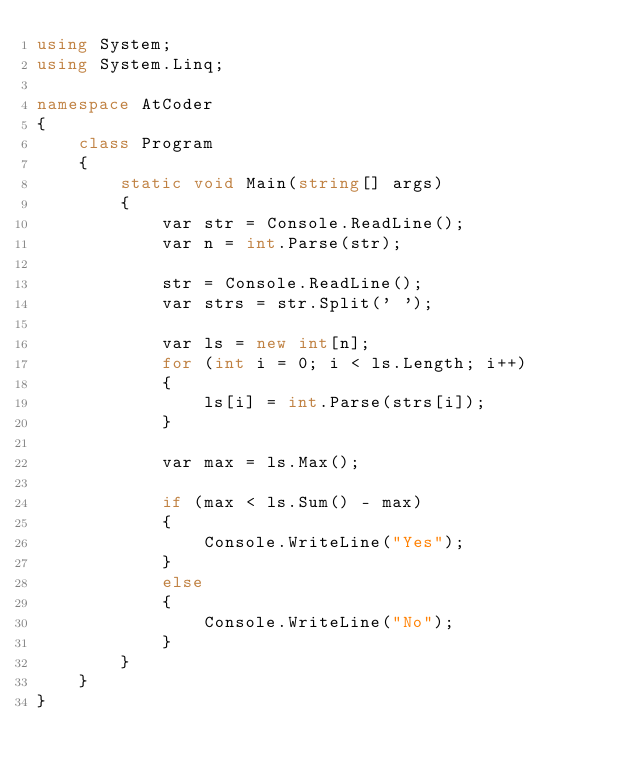<code> <loc_0><loc_0><loc_500><loc_500><_C#_>using System;
using System.Linq;

namespace AtCoder
{
    class Program
    {
        static void Main(string[] args)
        {
            var str = Console.ReadLine();
            var n = int.Parse(str);

            str = Console.ReadLine();
            var strs = str.Split(' ');

            var ls = new int[n];
            for (int i = 0; i < ls.Length; i++)
            {
                ls[i] = int.Parse(strs[i]);
            }

            var max = ls.Max();

            if (max < ls.Sum() - max)
            {
                Console.WriteLine("Yes");
            }
            else
            {
                Console.WriteLine("No");
            }
        }
    }
}
</code> 